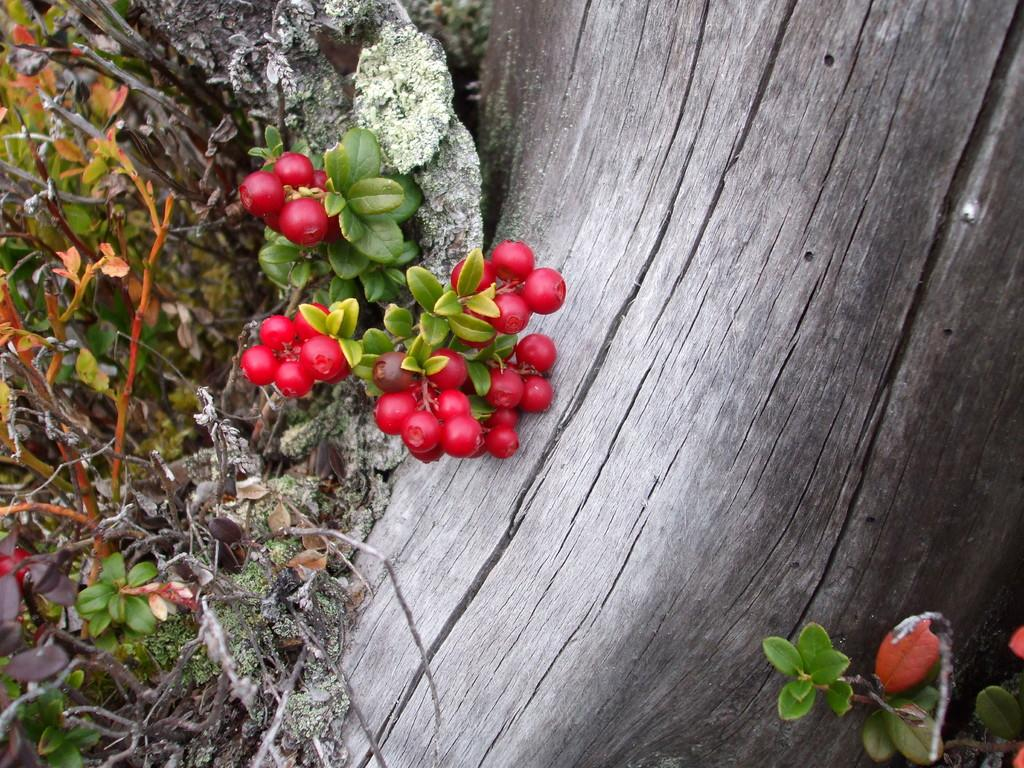What color are the fruits in the image? The fruits in the image are red. Where are the fruits located? The fruits are on a tree. What part of the tree can be seen in the image? Tree bark is visible in the image. Reasoning: Let's think step by step by step in order to produce the conversation. We start by identifying the main subject in the image, which is the red color fruits. Then, we expand the conversation to include the location of the fruits, which is on a tree. Finally, we mention a specific detail about the tree, which is the visible tree bark. Each question is designed to elicit a specific detail about the image that is known from the provided facts. Absurd Question/Answer: Can you see a river flowing near the tree in the image? No, there is no river visible in the image. 